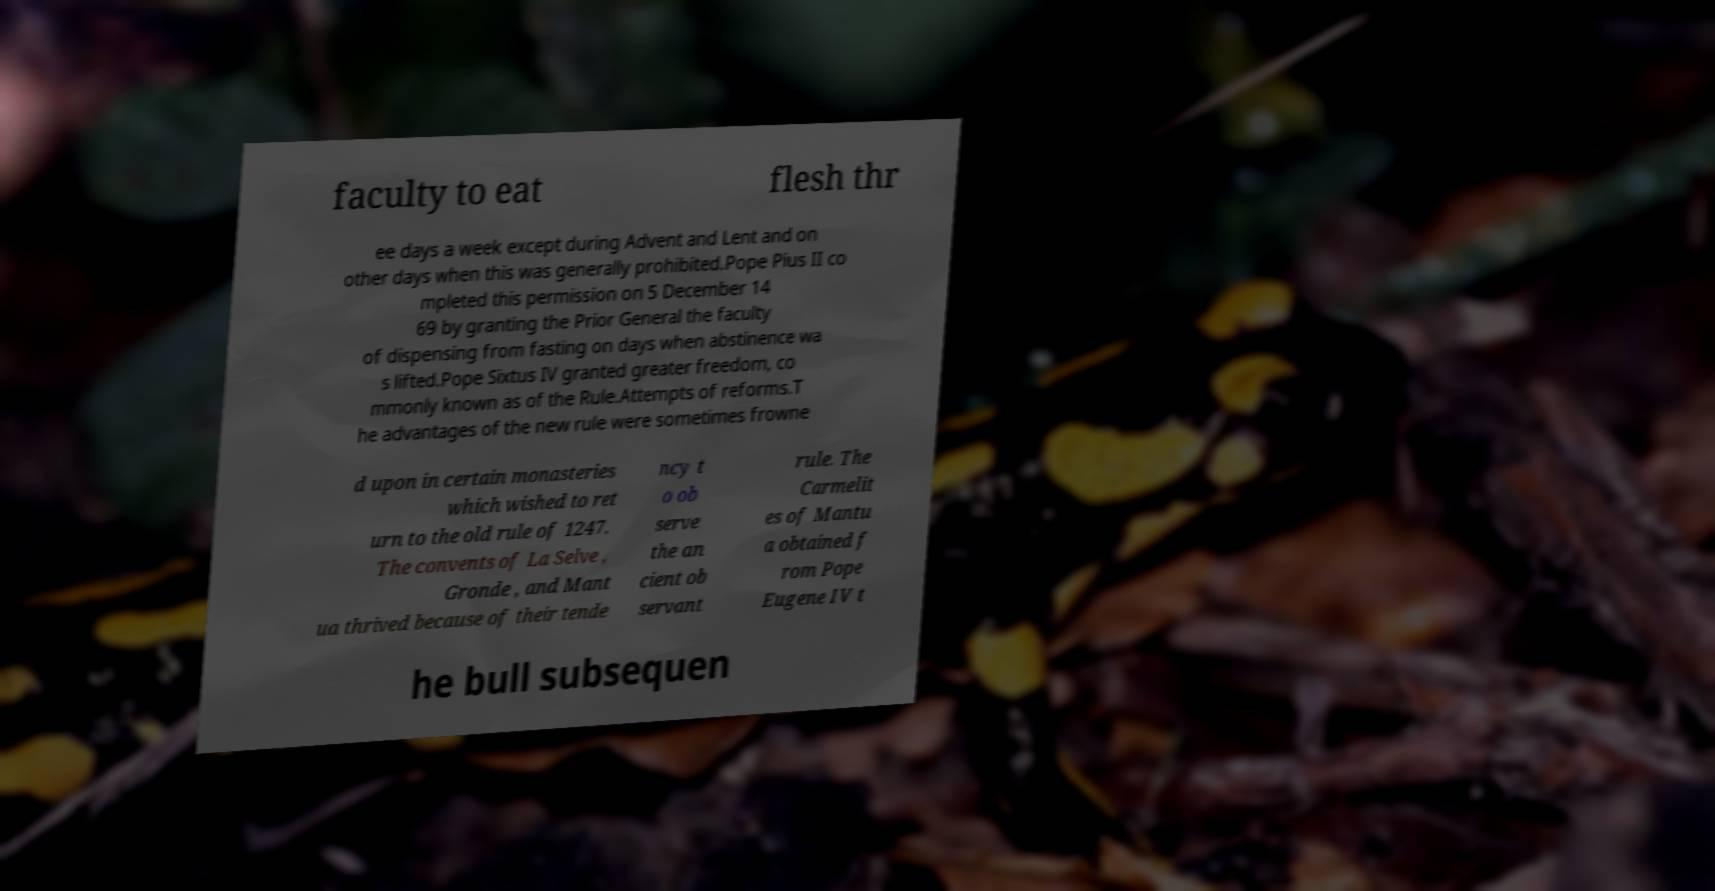I need the written content from this picture converted into text. Can you do that? faculty to eat flesh thr ee days a week except during Advent and Lent and on other days when this was generally prohibited.Pope Pius II co mpleted this permission on 5 December 14 69 by granting the Prior General the faculty of dispensing from fasting on days when abstinence wa s lifted.Pope Sixtus IV granted greater freedom, co mmonly known as of the Rule.Attempts of reforms.T he advantages of the new rule were sometimes frowne d upon in certain monasteries which wished to ret urn to the old rule of 1247. The convents of La Selve , Gronde , and Mant ua thrived because of their tende ncy t o ob serve the an cient ob servant rule. The Carmelit es of Mantu a obtained f rom Pope Eugene IV t he bull subsequen 